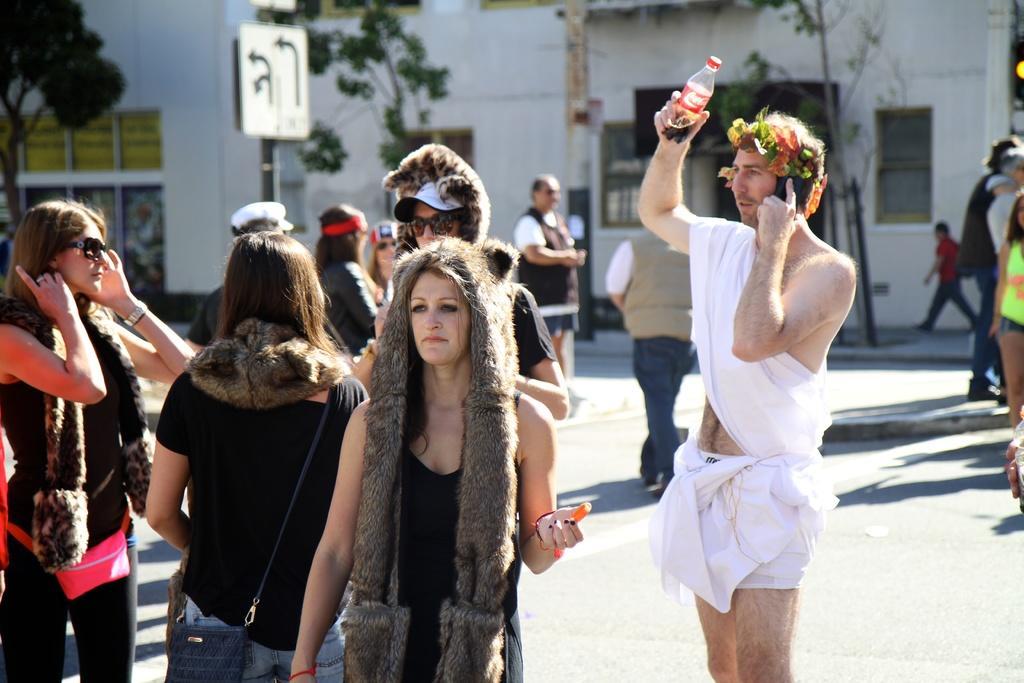Could you give a brief overview of what you see in this image? In this image I can see a crowd on the road. In the background I can see buildings, trees, boards and windows. This image is taken during a sunny day. 